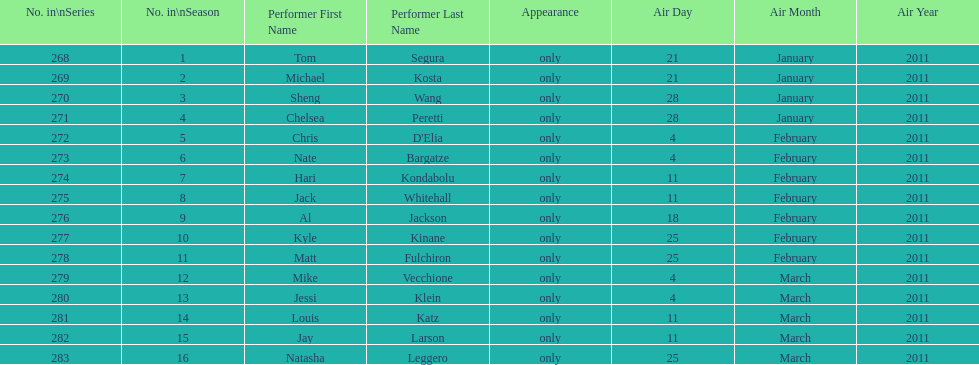How many comedians made their only appearance on comedy central presents in season 15? 16. 